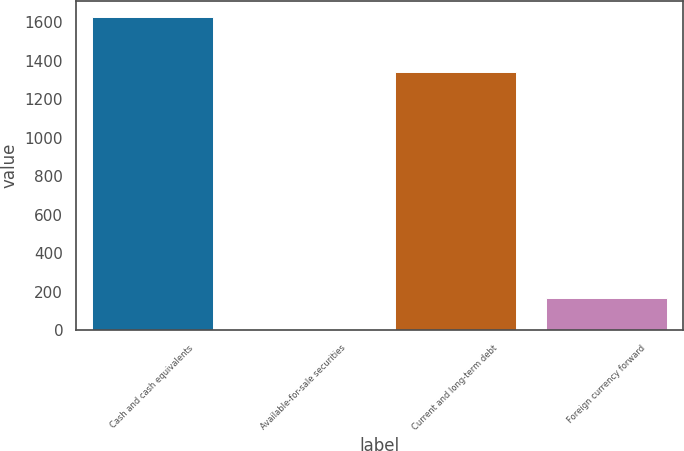Convert chart to OTSL. <chart><loc_0><loc_0><loc_500><loc_500><bar_chart><fcel>Cash and cash equivalents<fcel>Available-for-sale securities<fcel>Current and long-term debt<fcel>Foreign currency forward<nl><fcel>1629.1<fcel>7.6<fcel>1343.1<fcel>169.75<nl></chart> 